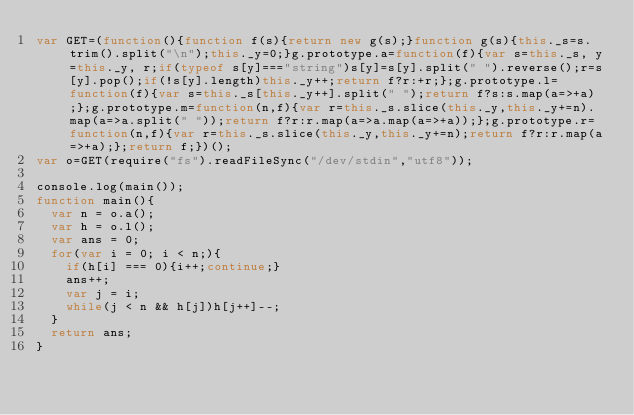Convert code to text. <code><loc_0><loc_0><loc_500><loc_500><_JavaScript_>var GET=(function(){function f(s){return new g(s);}function g(s){this._s=s.trim().split("\n");this._y=0;}g.prototype.a=function(f){var s=this._s, y=this._y, r;if(typeof s[y]==="string")s[y]=s[y].split(" ").reverse();r=s[y].pop();if(!s[y].length)this._y++;return f?r:+r;};g.prototype.l=function(f){var s=this._s[this._y++].split(" ");return f?s:s.map(a=>+a);};g.prototype.m=function(n,f){var r=this._s.slice(this._y,this._y+=n).map(a=>a.split(" "));return f?r:r.map(a=>a.map(a=>+a));};g.prototype.r=function(n,f){var r=this._s.slice(this._y,this._y+=n);return f?r:r.map(a=>+a);};return f;})();
var o=GET(require("fs").readFileSync("/dev/stdin","utf8"));

console.log(main());
function main(){
  var n = o.a();
  var h = o.l();
  var ans = 0;
  for(var i = 0; i < n;){
    if(h[i] === 0){i++;continue;}
    ans++;
    var j = i;
    while(j < n && h[j])h[j++]--;
  }
  return ans;
}</code> 